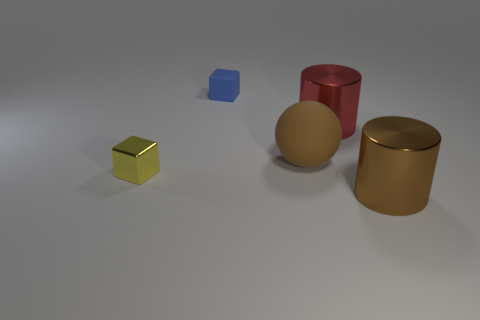Add 3 tiny gray metal balls. How many objects exist? 8 Subtract all cubes. How many objects are left? 3 Subtract 1 brown spheres. How many objects are left? 4 Subtract all purple metallic blocks. Subtract all large metal objects. How many objects are left? 3 Add 5 matte blocks. How many matte blocks are left? 6 Add 1 cylinders. How many cylinders exist? 3 